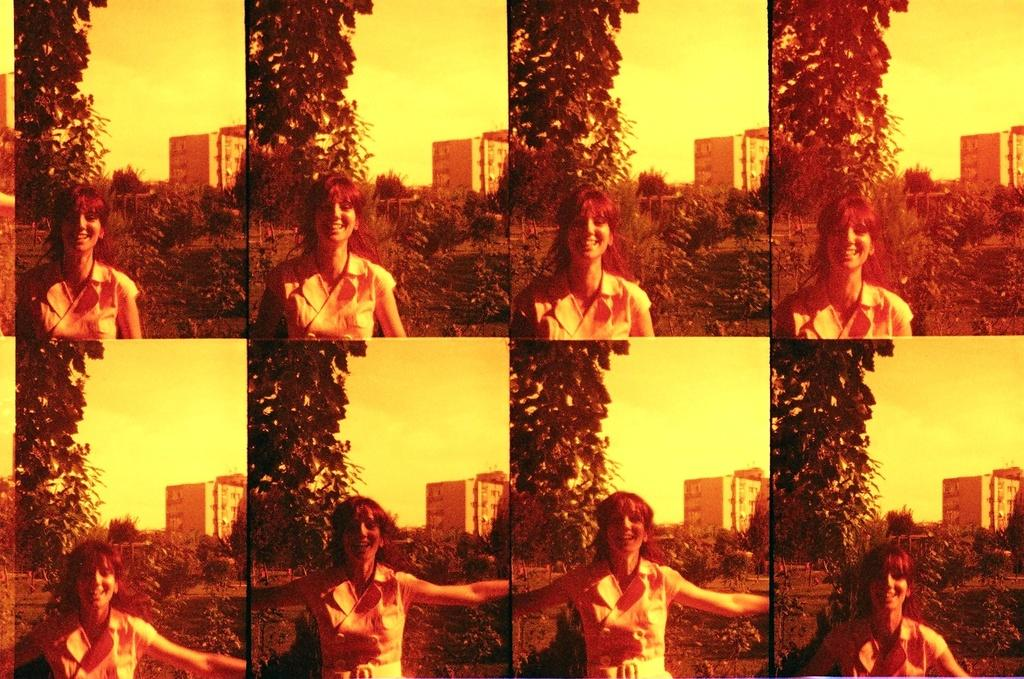What type of artwork is shown in the image? The image is a collage of multiple images. Can you describe one of the images within the collage? In one of the images, there is a woman with a smiley face. What common elements can be found in each image of the collage? In each image, there are plants, trees, buildings, and sky. What type of learning can be observed in the image? There is no learning activity depicted in the image; it is a collage of multiple images featuring plants, trees, buildings, and sky. Can you tell me how many dolls are present in the image? There are no dolls present in the image; it is a collage of multiple images featuring plants, trees, buildings, and sky. 